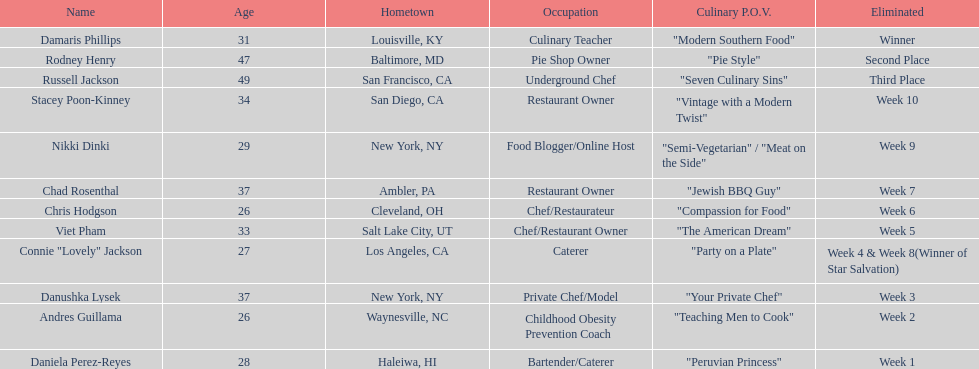Which food network star participants are in their twenties? Nikki Dinki, Chris Hodgson, Connie "Lovely" Jackson, Andres Guillama, Daniela Perez-Reyes. Among these participants, who has the same age as chris hodgson? Andres Guillama. 